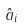Convert formula to latex. <formula><loc_0><loc_0><loc_500><loc_500>\hat { a } _ { i }</formula> 